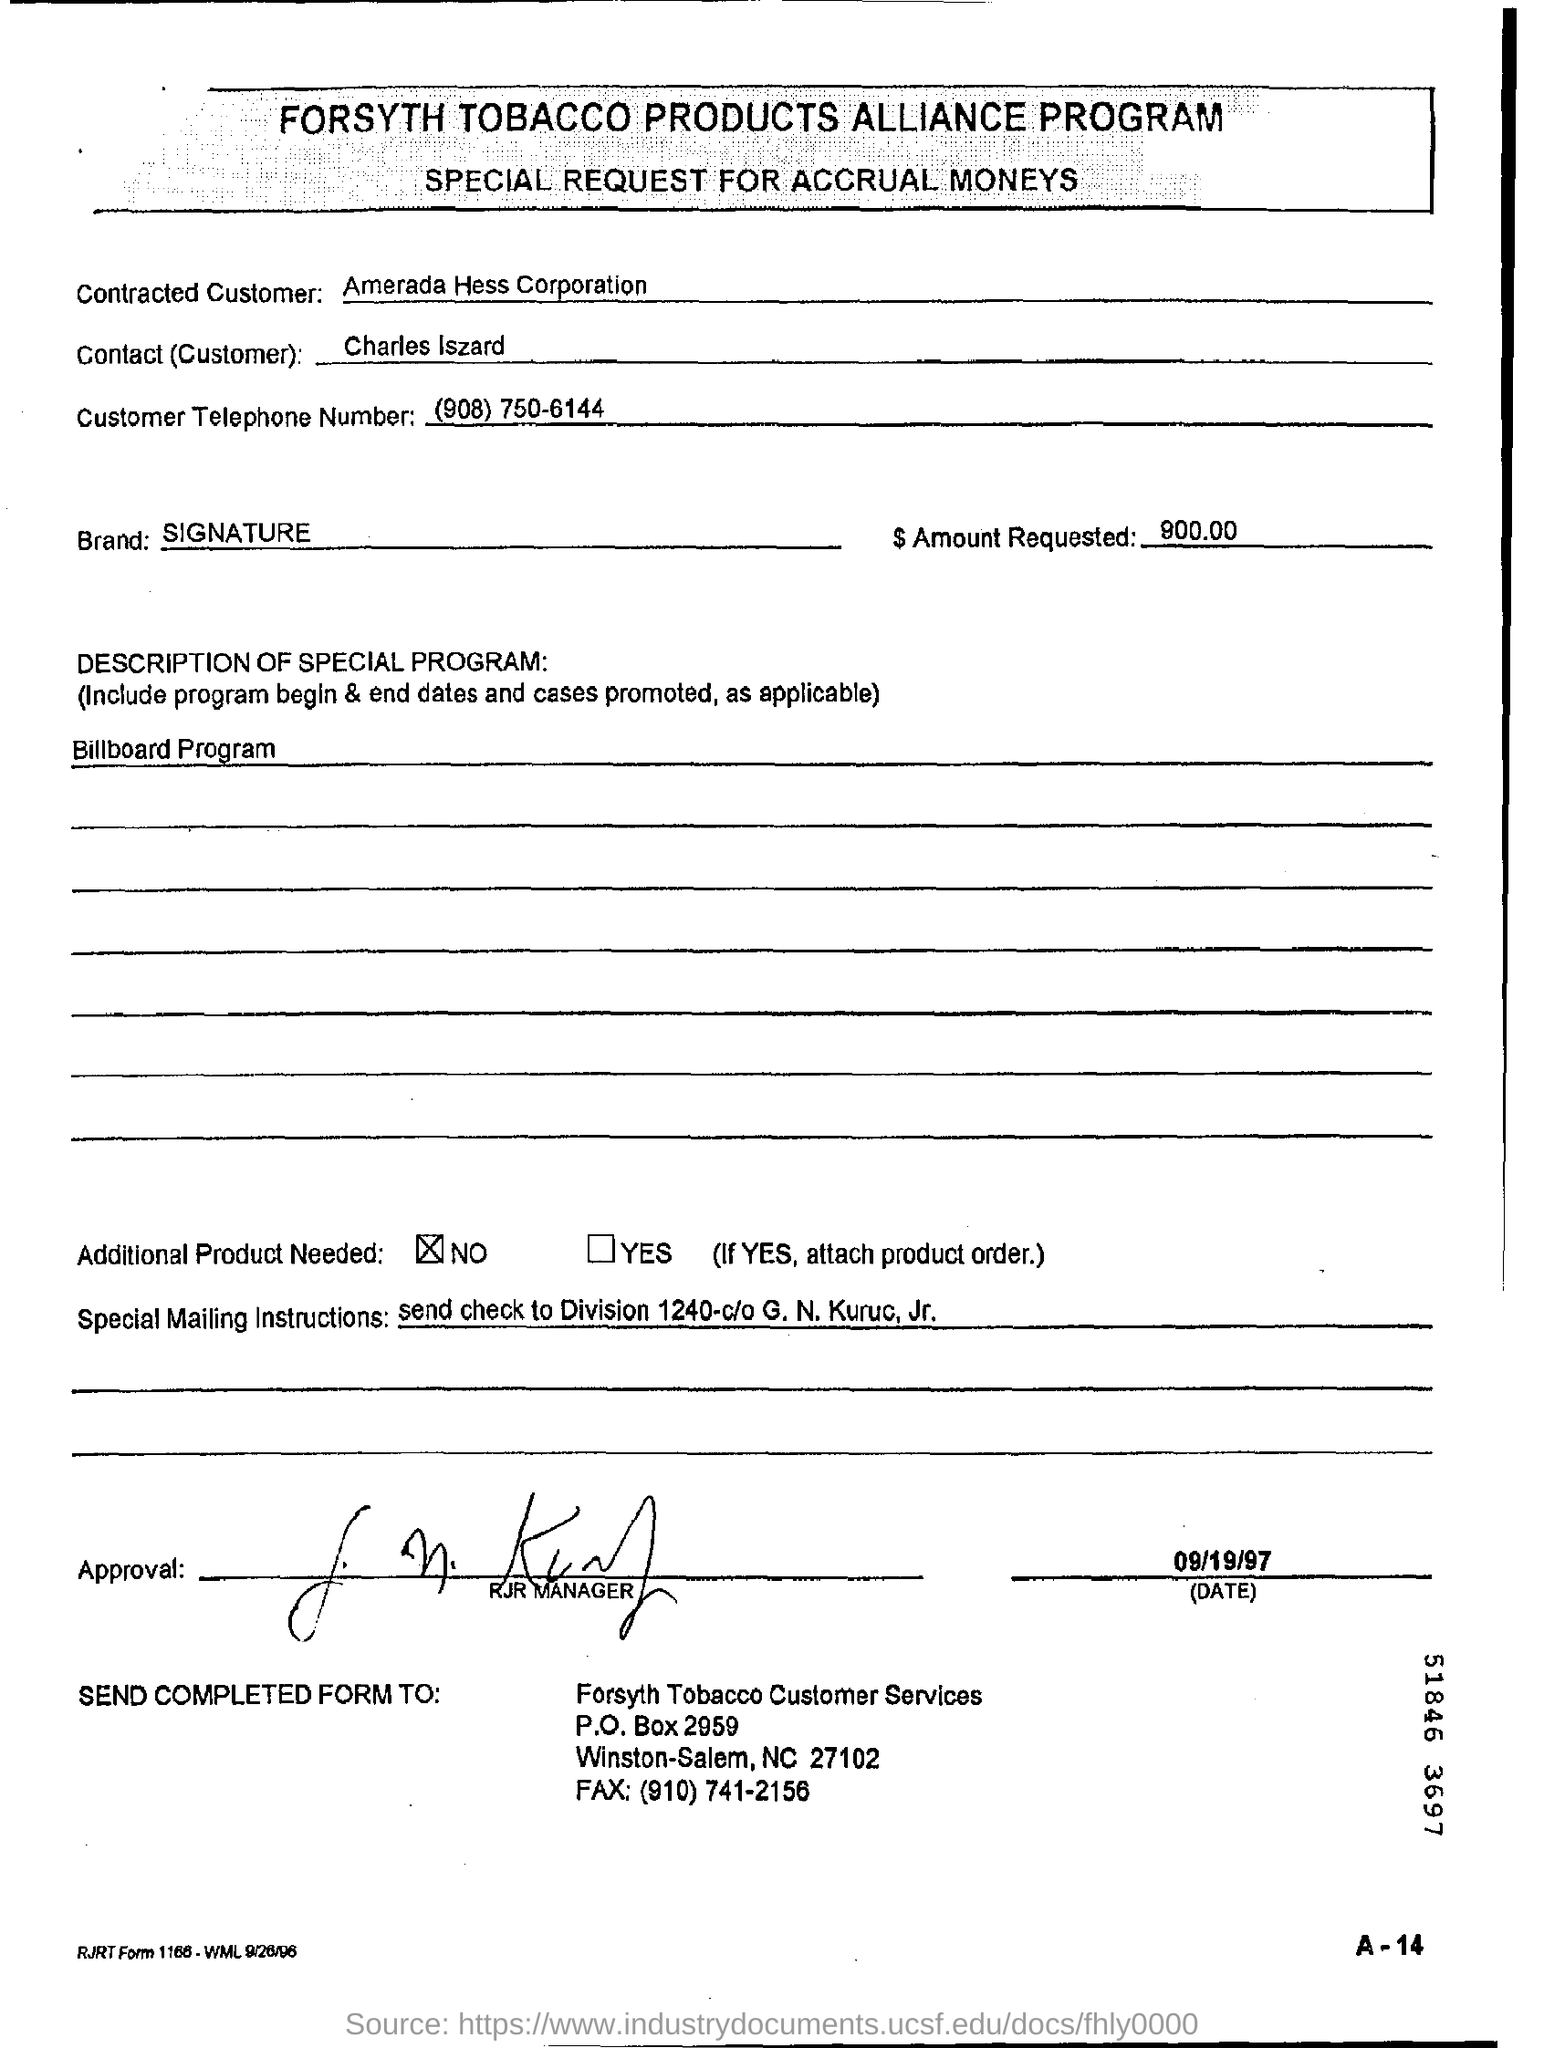Specify some key components in this picture. The message states that the sender requires specific mailing instructions, which are to send a check to "Division 1240-c/o G. N. kuruc, Jr. The completed form should be sent to Forsyth Tobacco customer services. The special request is for accrual moneys. The customer who is contracted is Amerada Hess Corporation. What is the customer's telephone number? It is (908) 750-6144. 